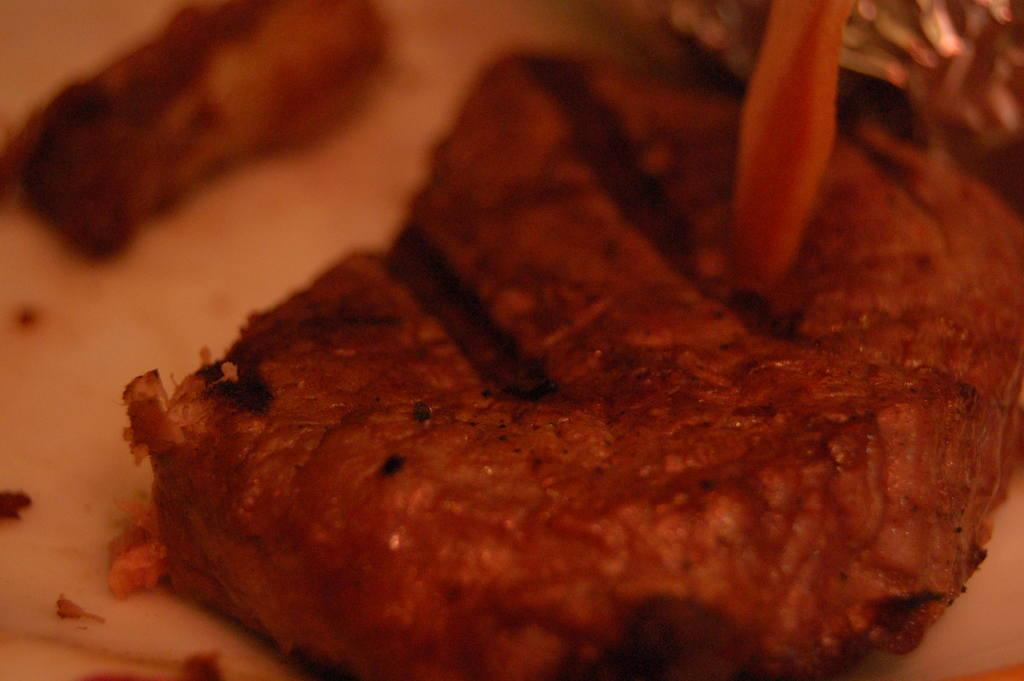What type of food can be seen in the image? There is some food visible in the image. What type of bread is being worn by the angle in the image? There is no bread, angle, or dress present in the image. 